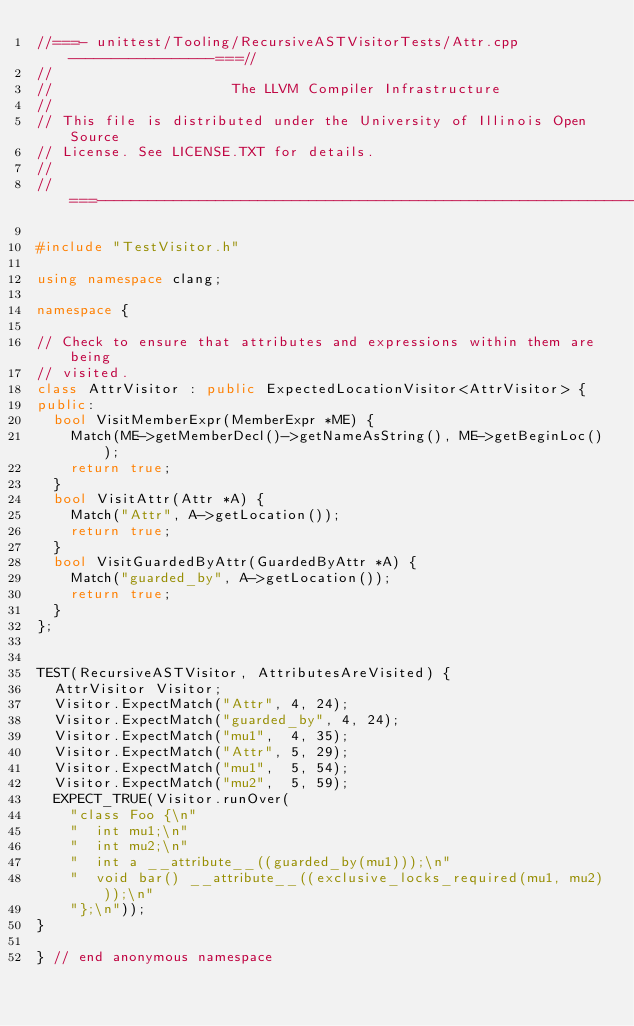<code> <loc_0><loc_0><loc_500><loc_500><_C++_>//===- unittest/Tooling/RecursiveASTVisitorTests/Attr.cpp -----------------===//
//
//                     The LLVM Compiler Infrastructure
//
// This file is distributed under the University of Illinois Open Source
// License. See LICENSE.TXT for details.
//
//===----------------------------------------------------------------------===//

#include "TestVisitor.h"

using namespace clang;

namespace {

// Check to ensure that attributes and expressions within them are being
// visited.
class AttrVisitor : public ExpectedLocationVisitor<AttrVisitor> {
public:
  bool VisitMemberExpr(MemberExpr *ME) {
    Match(ME->getMemberDecl()->getNameAsString(), ME->getBeginLoc());
    return true;
  }
  bool VisitAttr(Attr *A) {
    Match("Attr", A->getLocation());
    return true;
  }
  bool VisitGuardedByAttr(GuardedByAttr *A) {
    Match("guarded_by", A->getLocation());
    return true;
  }
};


TEST(RecursiveASTVisitor, AttributesAreVisited) {
  AttrVisitor Visitor;
  Visitor.ExpectMatch("Attr", 4, 24);
  Visitor.ExpectMatch("guarded_by", 4, 24);
  Visitor.ExpectMatch("mu1",  4, 35);
  Visitor.ExpectMatch("Attr", 5, 29);
  Visitor.ExpectMatch("mu1",  5, 54);
  Visitor.ExpectMatch("mu2",  5, 59);
  EXPECT_TRUE(Visitor.runOver(
    "class Foo {\n"
    "  int mu1;\n"
    "  int mu2;\n"
    "  int a __attribute__((guarded_by(mu1)));\n"
    "  void bar() __attribute__((exclusive_locks_required(mu1, mu2)));\n"
    "};\n"));
}

} // end anonymous namespace
</code> 